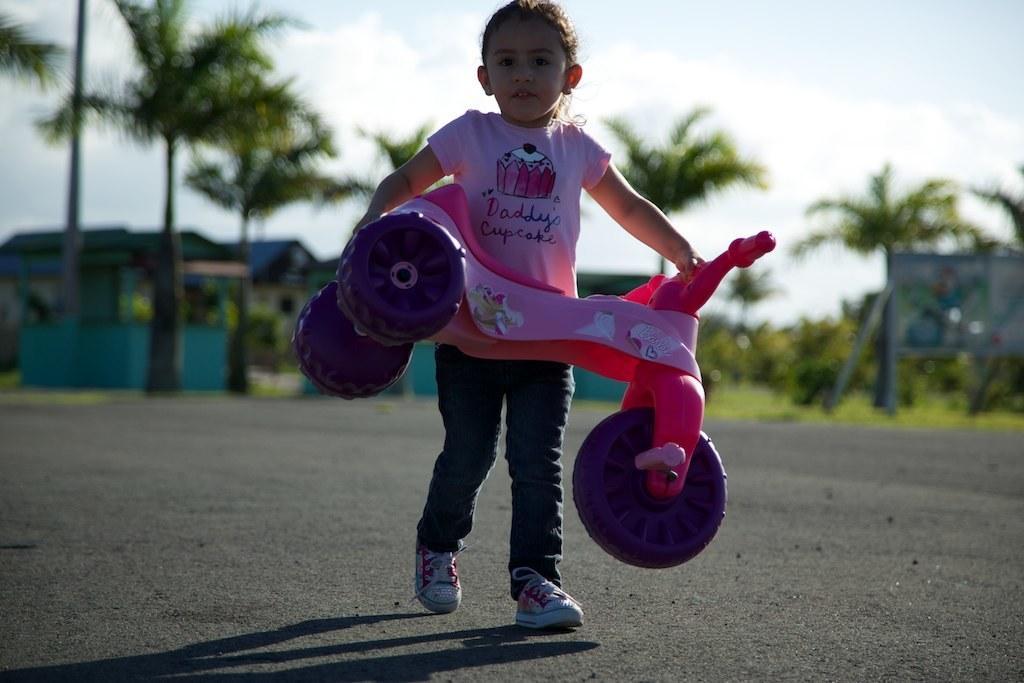Describe this image in one or two sentences. In this picture there is a girl who is wearing pink dress, jeans and shoe. She is holding toy vehicle. In the background we can see buildings, trees, plants and grass. On the top we can see sky and clouds. 